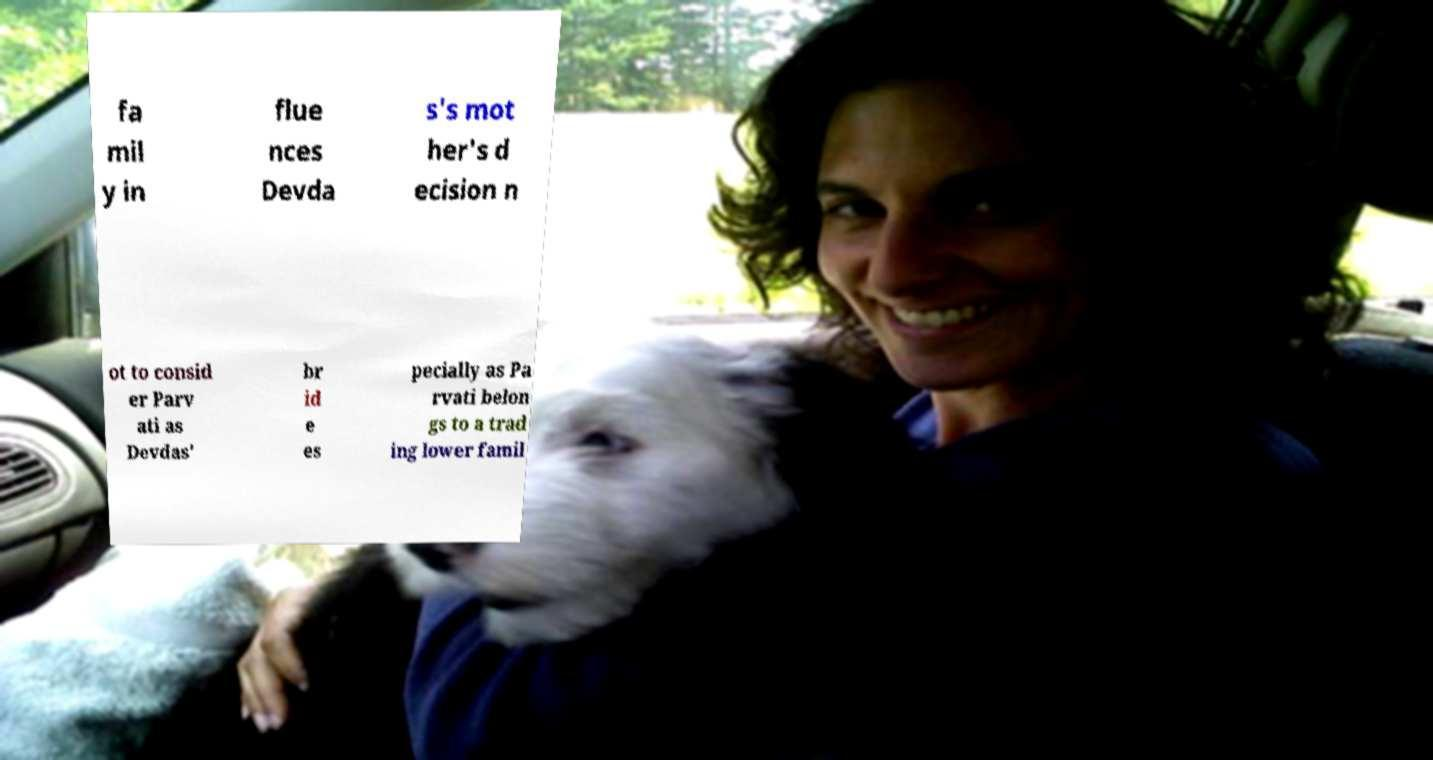Could you extract and type out the text from this image? fa mil y in flue nces Devda s's mot her's d ecision n ot to consid er Parv ati as Devdas' br id e es pecially as Pa rvati belon gs to a trad ing lower famil 